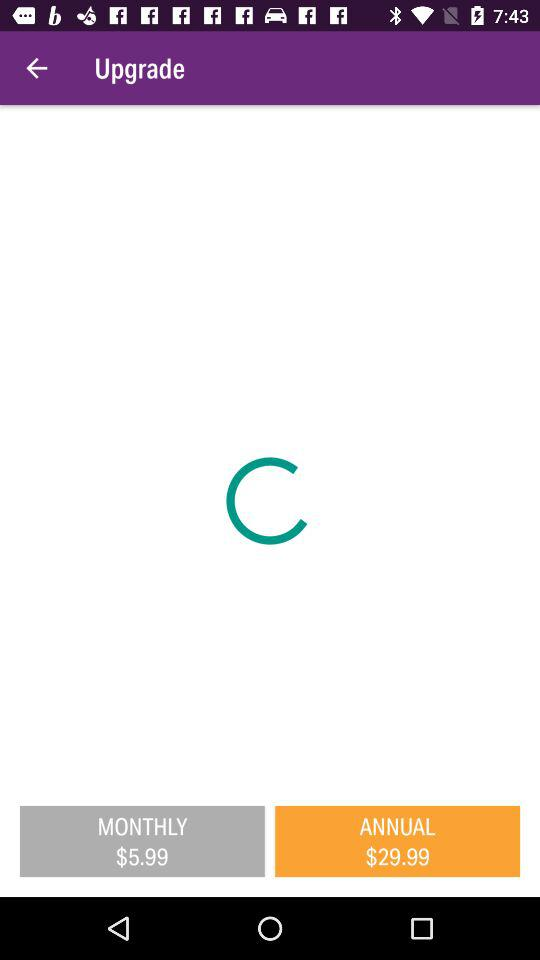What are the annual charges? The annual charges are $29.99. 